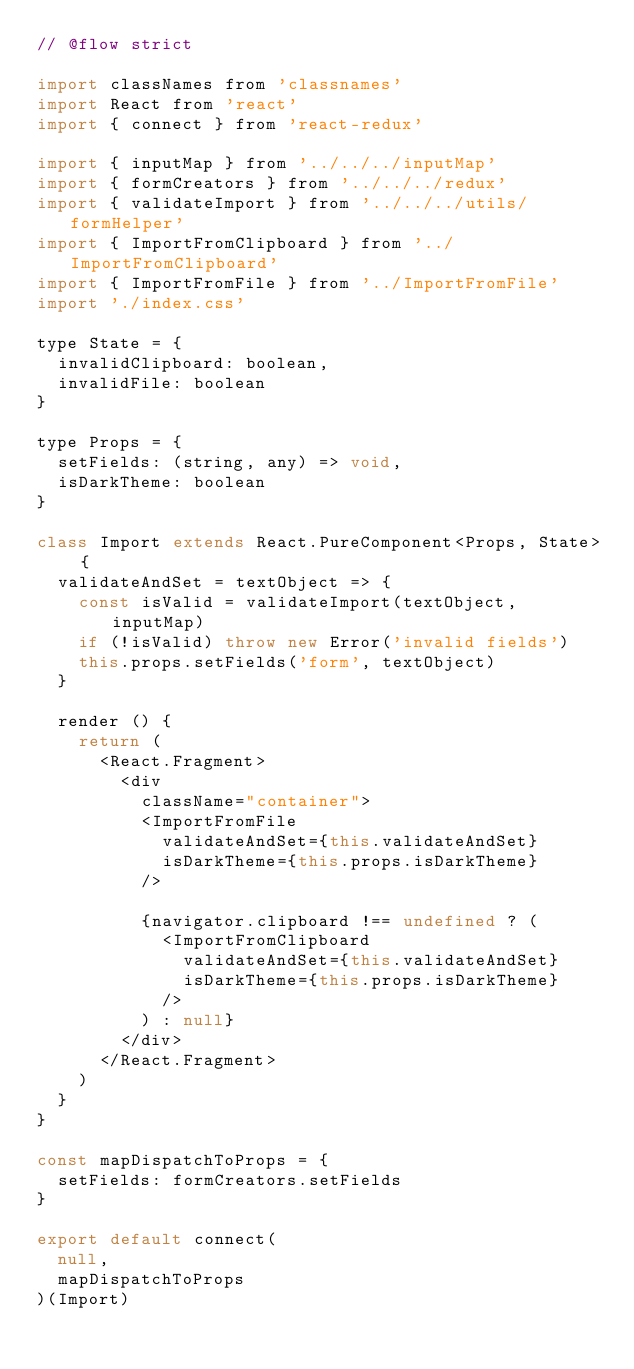<code> <loc_0><loc_0><loc_500><loc_500><_JavaScript_>// @flow strict

import classNames from 'classnames'
import React from 'react'
import { connect } from 'react-redux'

import { inputMap } from '../../../inputMap'
import { formCreators } from '../../../redux'
import { validateImport } from '../../../utils/formHelper'
import { ImportFromClipboard } from '../ImportFromClipboard'
import { ImportFromFile } from '../ImportFromFile'
import './index.css'

type State = {
  invalidClipboard: boolean,
  invalidFile: boolean
}

type Props = {
  setFields: (string, any) => void,
  isDarkTheme: boolean
}

class Import extends React.PureComponent<Props, State> {
  validateAndSet = textObject => {
    const isValid = validateImport(textObject, inputMap)
    if (!isValid) throw new Error('invalid fields')
    this.props.setFields('form', textObject)
  }

  render () {
    return (
      <React.Fragment>
        <div
          className="container">
          <ImportFromFile
            validateAndSet={this.validateAndSet}
            isDarkTheme={this.props.isDarkTheme}
          />

          {navigator.clipboard !== undefined ? (
            <ImportFromClipboard
              validateAndSet={this.validateAndSet}
              isDarkTheme={this.props.isDarkTheme}
            />
          ) : null}
        </div>
      </React.Fragment>
    )
  }
}

const mapDispatchToProps = {
  setFields: formCreators.setFields
}

export default connect(
  null,
  mapDispatchToProps
)(Import)
</code> 